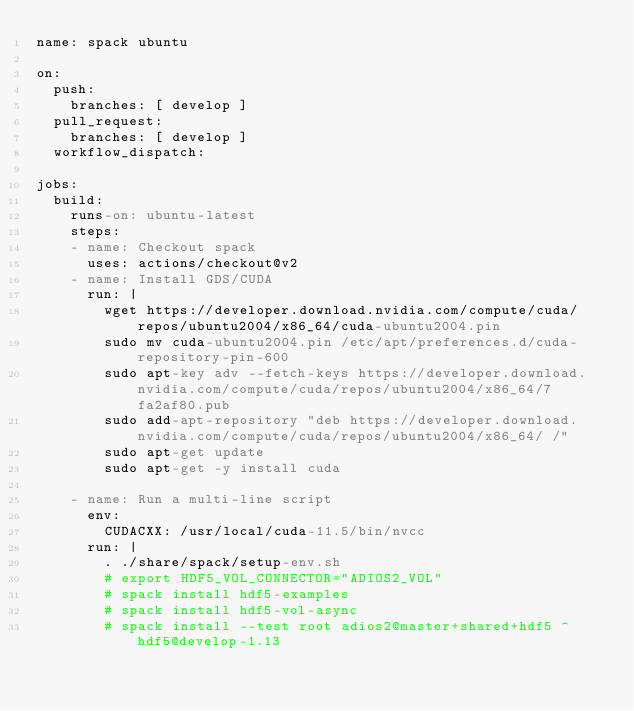Convert code to text. <code><loc_0><loc_0><loc_500><loc_500><_YAML_>name: spack ubuntu

on:
  push:
    branches: [ develop ]
  pull_request:
    branches: [ develop ]
  workflow_dispatch:

jobs:
  build:
    runs-on: ubuntu-latest
    steps:
    - name: Checkout spack
      uses: actions/checkout@v2
    - name: Install GDS/CUDA
      run: |
        wget https://developer.download.nvidia.com/compute/cuda/repos/ubuntu2004/x86_64/cuda-ubuntu2004.pin
        sudo mv cuda-ubuntu2004.pin /etc/apt/preferences.d/cuda-repository-pin-600
        sudo apt-key adv --fetch-keys https://developer.download.nvidia.com/compute/cuda/repos/ubuntu2004/x86_64/7fa2af80.pub
        sudo add-apt-repository "deb https://developer.download.nvidia.com/compute/cuda/repos/ubuntu2004/x86_64/ /"
        sudo apt-get update
        sudo apt-get -y install cuda

    - name: Run a multi-line script
      env:
        CUDACXX: /usr/local/cuda-11.5/bin/nvcc
      run: |
        . ./share/spack/setup-env.sh
        # export HDF5_VOL_CONNECTOR="ADIOS2_VOL"
        # spack install hdf5-examples
        # spack install hdf5-vol-async
        # spack install --test root adios2@master+shared+hdf5 ^hdf5@develop-1.13</code> 